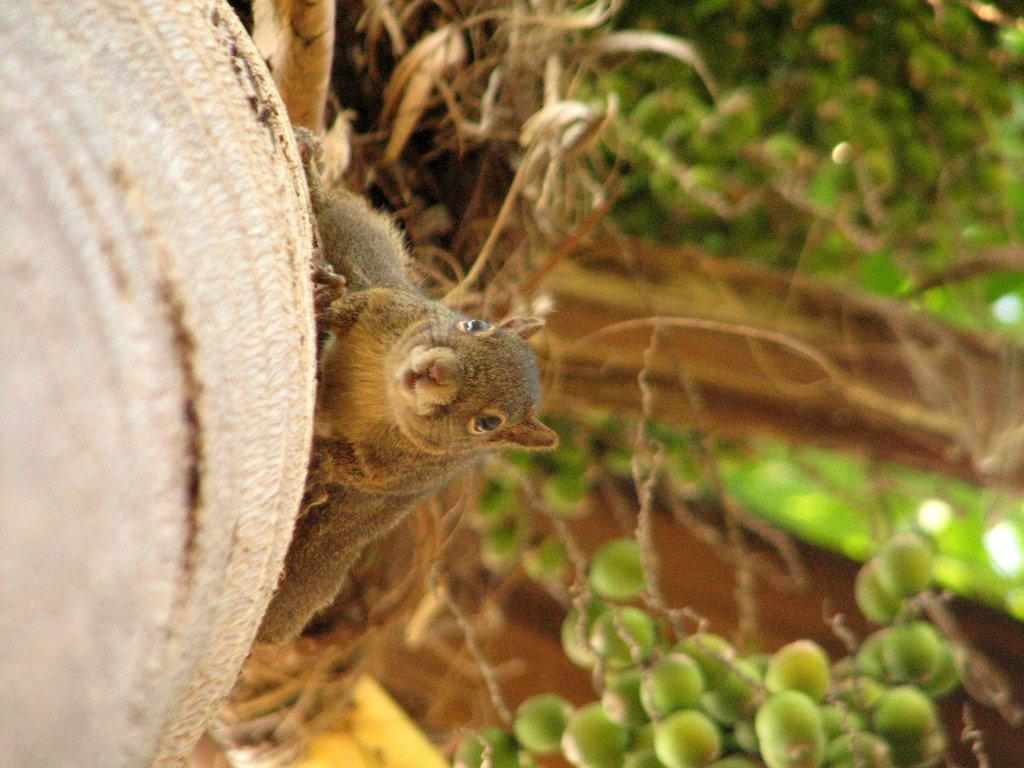What is located on the left side of the image? There is a tree on the left side of the image. What animal can be seen in the center of the image? There is a squirrel in the center of the image. Can you describe the background of the image? The background of the image is blurred. What type of prose is being recited by the squirrel in the image? There is no indication in the image that the squirrel is reciting any prose. What is the texture of the tree on the left side of the image? The texture of the tree cannot be determined from the image alone, as it is a two-dimensional representation. 